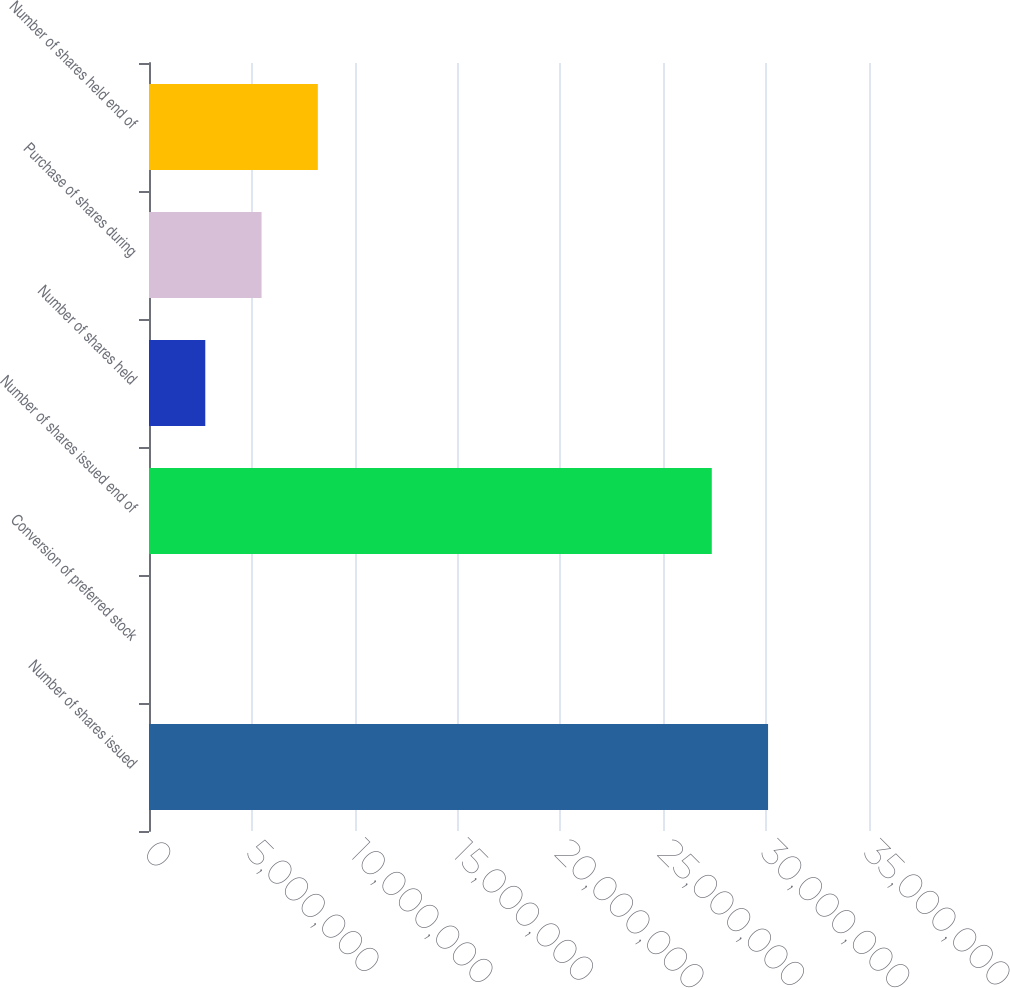<chart> <loc_0><loc_0><loc_500><loc_500><bar_chart><fcel>Number of shares issued<fcel>Conversion of preferred stock<fcel>Number of shares issued end of<fcel>Number of shares held<fcel>Purchase of shares during<fcel>Number of shares held end of<nl><fcel>3.00934e+07<fcel>485<fcel>2.73576e+07<fcel>2.73624e+06<fcel>5.472e+06<fcel>8.20776e+06<nl></chart> 